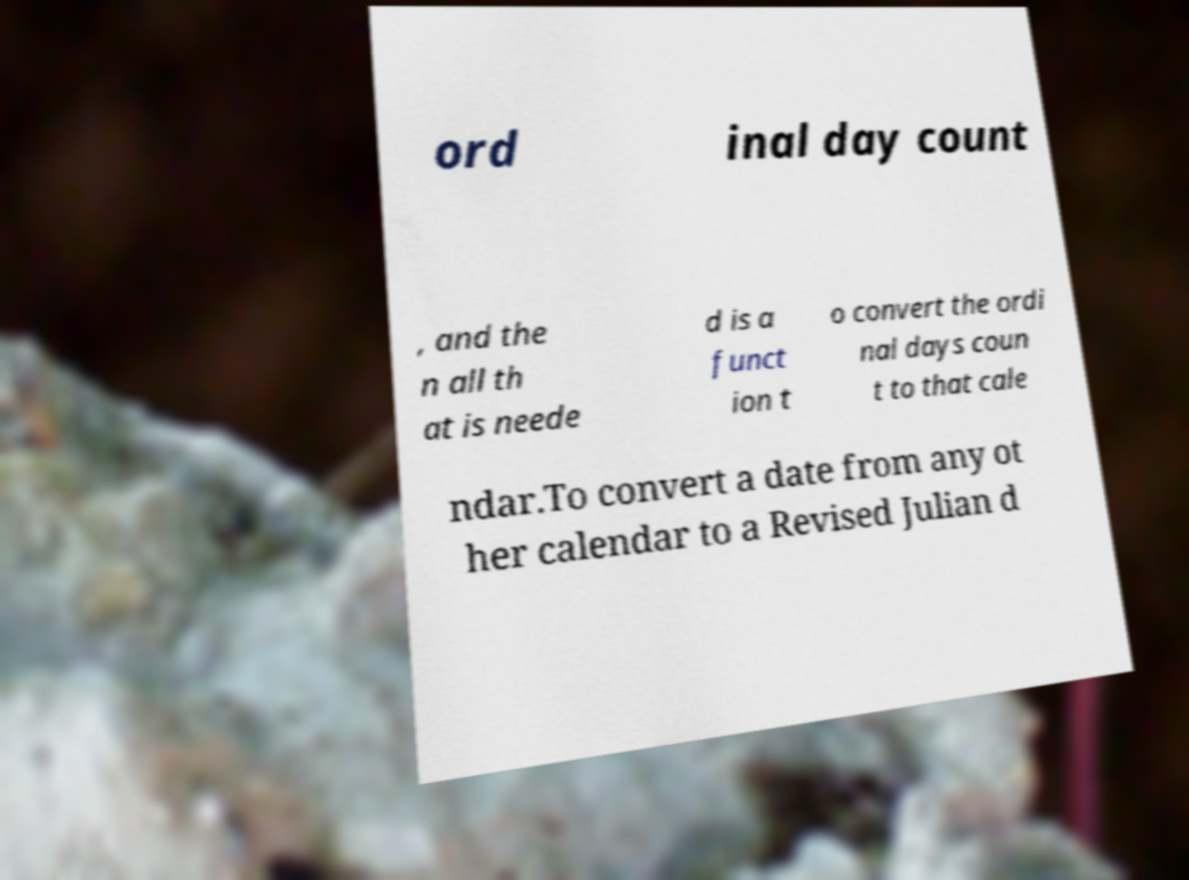Can you accurately transcribe the text from the provided image for me? ord inal day count , and the n all th at is neede d is a funct ion t o convert the ordi nal days coun t to that cale ndar.To convert a date from any ot her calendar to a Revised Julian d 